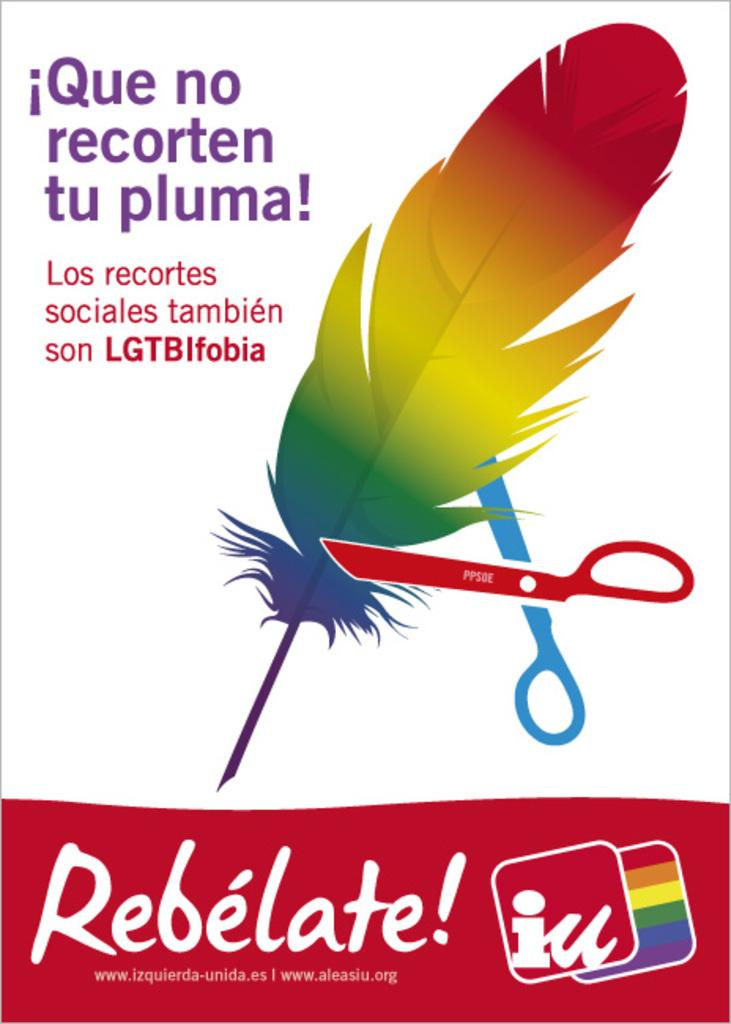<image>
Give a short and clear explanation of the subsequent image. A feather being cut by scissors wih Que no recorten tu pluma in the left corner. 